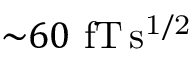<formula> <loc_0><loc_0><loc_500><loc_500>{ \sim } 6 0 f T \, s ^ { 1 / 2 }</formula> 